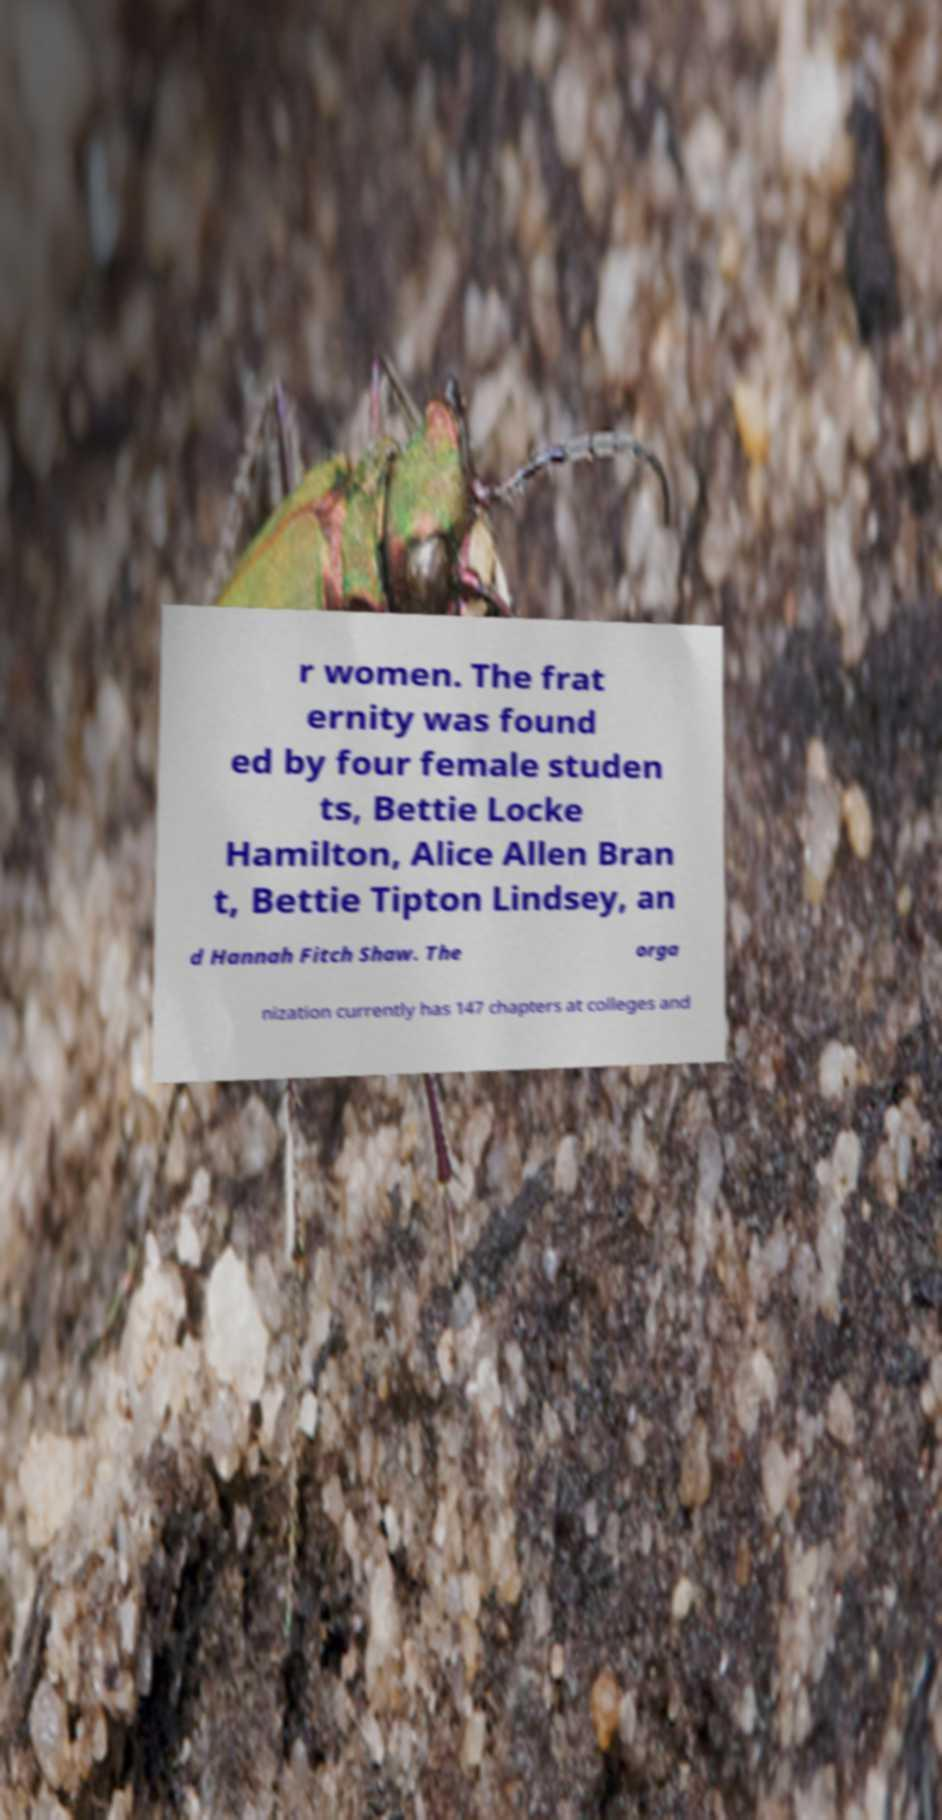Can you read and provide the text displayed in the image?This photo seems to have some interesting text. Can you extract and type it out for me? r women. The frat ernity was found ed by four female studen ts, Bettie Locke Hamilton, Alice Allen Bran t, Bettie Tipton Lindsey, an d Hannah Fitch Shaw. The orga nization currently has 147 chapters at colleges and 